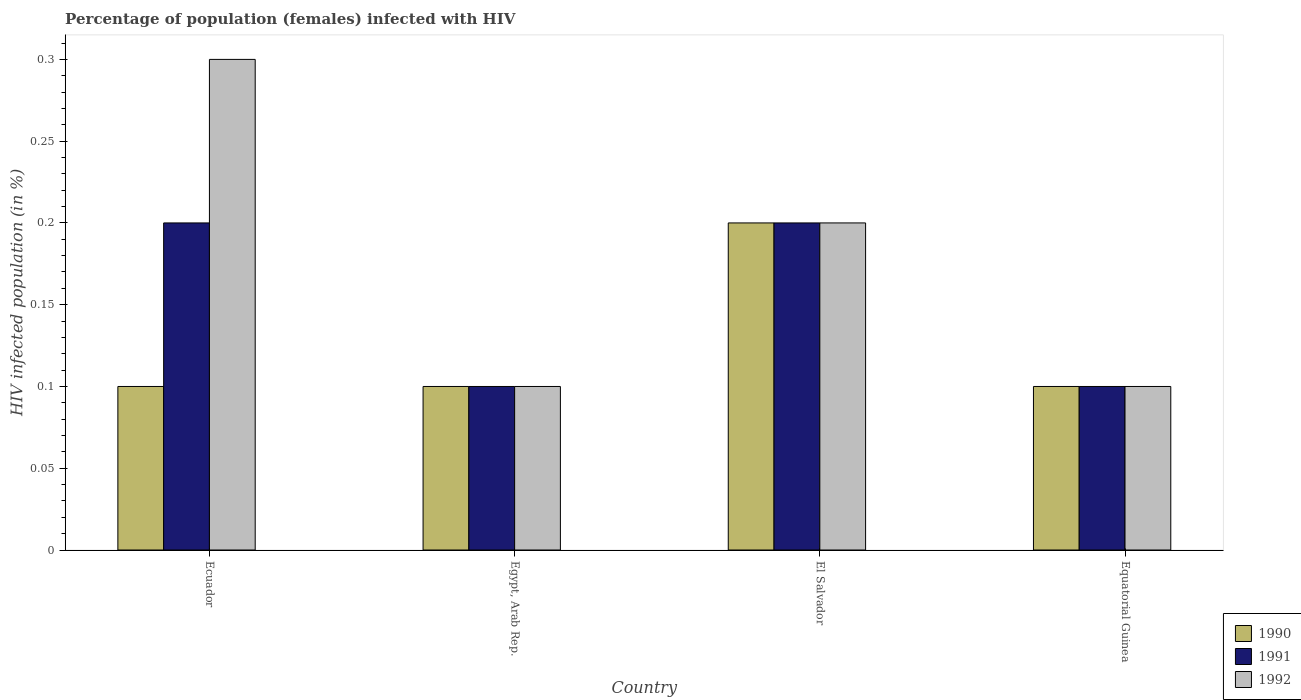How many different coloured bars are there?
Your answer should be very brief. 3. How many groups of bars are there?
Your answer should be compact. 4. How many bars are there on the 2nd tick from the left?
Keep it short and to the point. 3. What is the label of the 2nd group of bars from the left?
Make the answer very short. Egypt, Arab Rep. In how many cases, is the number of bars for a given country not equal to the number of legend labels?
Give a very brief answer. 0. What is the percentage of HIV infected female population in 1990 in Equatorial Guinea?
Your answer should be very brief. 0.1. In which country was the percentage of HIV infected female population in 1990 maximum?
Make the answer very short. El Salvador. In which country was the percentage of HIV infected female population in 1991 minimum?
Your answer should be compact. Egypt, Arab Rep. What is the difference between the percentage of HIV infected female population in 1990 in Egypt, Arab Rep. and the percentage of HIV infected female population in 1991 in Ecuador?
Offer a terse response. -0.1. What is the ratio of the percentage of HIV infected female population in 1990 in Egypt, Arab Rep. to that in El Salvador?
Ensure brevity in your answer.  0.5. Is the difference between the percentage of HIV infected female population in 1990 in Ecuador and Equatorial Guinea greater than the difference between the percentage of HIV infected female population in 1992 in Ecuador and Equatorial Guinea?
Keep it short and to the point. No. What is the difference between the highest and the second highest percentage of HIV infected female population in 1991?
Your answer should be very brief. 0.1. What does the 1st bar from the left in Equatorial Guinea represents?
Ensure brevity in your answer.  1990. Is it the case that in every country, the sum of the percentage of HIV infected female population in 1991 and percentage of HIV infected female population in 1992 is greater than the percentage of HIV infected female population in 1990?
Offer a terse response. Yes. Are the values on the major ticks of Y-axis written in scientific E-notation?
Your answer should be compact. No. Does the graph contain any zero values?
Offer a terse response. No. Where does the legend appear in the graph?
Provide a succinct answer. Bottom right. How many legend labels are there?
Provide a short and direct response. 3. What is the title of the graph?
Provide a succinct answer. Percentage of population (females) infected with HIV. Does "2003" appear as one of the legend labels in the graph?
Your answer should be very brief. No. What is the label or title of the Y-axis?
Your answer should be very brief. HIV infected population (in %). What is the HIV infected population (in %) of 1990 in Ecuador?
Give a very brief answer. 0.1. What is the HIV infected population (in %) in 1990 in Egypt, Arab Rep.?
Give a very brief answer. 0.1. What is the HIV infected population (in %) in 1991 in El Salvador?
Give a very brief answer. 0.2. Across all countries, what is the maximum HIV infected population (in %) in 1990?
Offer a very short reply. 0.2. Across all countries, what is the minimum HIV infected population (in %) in 1990?
Offer a very short reply. 0.1. Across all countries, what is the minimum HIV infected population (in %) in 1991?
Offer a very short reply. 0.1. What is the total HIV infected population (in %) in 1992 in the graph?
Give a very brief answer. 0.7. What is the difference between the HIV infected population (in %) of 1991 in Ecuador and that in El Salvador?
Offer a terse response. 0. What is the difference between the HIV infected population (in %) of 1992 in Ecuador and that in El Salvador?
Your answer should be compact. 0.1. What is the difference between the HIV infected population (in %) of 1990 in Ecuador and that in Equatorial Guinea?
Provide a succinct answer. 0. What is the difference between the HIV infected population (in %) in 1992 in Ecuador and that in Equatorial Guinea?
Your answer should be compact. 0.2. What is the difference between the HIV infected population (in %) in 1991 in Egypt, Arab Rep. and that in El Salvador?
Your response must be concise. -0.1. What is the difference between the HIV infected population (in %) of 1991 in Egypt, Arab Rep. and that in Equatorial Guinea?
Make the answer very short. 0. What is the difference between the HIV infected population (in %) in 1991 in El Salvador and that in Equatorial Guinea?
Your answer should be very brief. 0.1. What is the difference between the HIV infected population (in %) of 1992 in El Salvador and that in Equatorial Guinea?
Ensure brevity in your answer.  0.1. What is the difference between the HIV infected population (in %) in 1990 in Ecuador and the HIV infected population (in %) in 1991 in Egypt, Arab Rep.?
Make the answer very short. 0. What is the difference between the HIV infected population (in %) of 1990 in Ecuador and the HIV infected population (in %) of 1992 in Egypt, Arab Rep.?
Provide a short and direct response. 0. What is the difference between the HIV infected population (in %) in 1991 in Ecuador and the HIV infected population (in %) in 1992 in Egypt, Arab Rep.?
Your response must be concise. 0.1. What is the difference between the HIV infected population (in %) of 1990 in Ecuador and the HIV infected population (in %) of 1992 in El Salvador?
Your answer should be compact. -0.1. What is the difference between the HIV infected population (in %) in 1990 in Ecuador and the HIV infected population (in %) in 1991 in Equatorial Guinea?
Provide a short and direct response. 0. What is the difference between the HIV infected population (in %) in 1991 in Ecuador and the HIV infected population (in %) in 1992 in Equatorial Guinea?
Keep it short and to the point. 0.1. What is the difference between the HIV infected population (in %) of 1990 in Egypt, Arab Rep. and the HIV infected population (in %) of 1992 in El Salvador?
Give a very brief answer. -0.1. What is the difference between the HIV infected population (in %) in 1990 in El Salvador and the HIV infected population (in %) in 1991 in Equatorial Guinea?
Make the answer very short. 0.1. What is the difference between the HIV infected population (in %) of 1990 in El Salvador and the HIV infected population (in %) of 1992 in Equatorial Guinea?
Ensure brevity in your answer.  0.1. What is the difference between the HIV infected population (in %) of 1991 in El Salvador and the HIV infected population (in %) of 1992 in Equatorial Guinea?
Provide a short and direct response. 0.1. What is the average HIV infected population (in %) of 1990 per country?
Give a very brief answer. 0.12. What is the average HIV infected population (in %) of 1992 per country?
Offer a terse response. 0.17. What is the difference between the HIV infected population (in %) in 1991 and HIV infected population (in %) in 1992 in Egypt, Arab Rep.?
Offer a very short reply. 0. What is the difference between the HIV infected population (in %) in 1991 and HIV infected population (in %) in 1992 in El Salvador?
Provide a short and direct response. 0. What is the difference between the HIV infected population (in %) of 1990 and HIV infected population (in %) of 1991 in Equatorial Guinea?
Give a very brief answer. 0. What is the difference between the HIV infected population (in %) of 1990 and HIV infected population (in %) of 1992 in Equatorial Guinea?
Your answer should be compact. 0. What is the ratio of the HIV infected population (in %) in 1990 in Ecuador to that in Egypt, Arab Rep.?
Provide a short and direct response. 1. What is the ratio of the HIV infected population (in %) in 1992 in Ecuador to that in Egypt, Arab Rep.?
Provide a succinct answer. 3. What is the ratio of the HIV infected population (in %) in 1990 in Ecuador to that in El Salvador?
Offer a very short reply. 0.5. What is the ratio of the HIV infected population (in %) in 1991 in Ecuador to that in El Salvador?
Your answer should be compact. 1. What is the ratio of the HIV infected population (in %) of 1992 in Ecuador to that in El Salvador?
Your response must be concise. 1.5. What is the ratio of the HIV infected population (in %) of 1990 in Ecuador to that in Equatorial Guinea?
Offer a very short reply. 1. What is the ratio of the HIV infected population (in %) in 1991 in Ecuador to that in Equatorial Guinea?
Your answer should be compact. 2. What is the ratio of the HIV infected population (in %) in 1992 in Ecuador to that in Equatorial Guinea?
Keep it short and to the point. 3. What is the ratio of the HIV infected population (in %) of 1990 in Egypt, Arab Rep. to that in El Salvador?
Your answer should be compact. 0.5. What is the ratio of the HIV infected population (in %) of 1991 in Egypt, Arab Rep. to that in El Salvador?
Give a very brief answer. 0.5. What is the ratio of the HIV infected population (in %) in 1992 in Egypt, Arab Rep. to that in El Salvador?
Your response must be concise. 0.5. What is the ratio of the HIV infected population (in %) in 1991 in Egypt, Arab Rep. to that in Equatorial Guinea?
Your response must be concise. 1. What is the ratio of the HIV infected population (in %) of 1992 in Egypt, Arab Rep. to that in Equatorial Guinea?
Your answer should be compact. 1. What is the ratio of the HIV infected population (in %) in 1990 in El Salvador to that in Equatorial Guinea?
Provide a short and direct response. 2. What is the ratio of the HIV infected population (in %) in 1992 in El Salvador to that in Equatorial Guinea?
Ensure brevity in your answer.  2. What is the difference between the highest and the second highest HIV infected population (in %) in 1991?
Your response must be concise. 0. What is the difference between the highest and the second highest HIV infected population (in %) in 1992?
Give a very brief answer. 0.1. What is the difference between the highest and the lowest HIV infected population (in %) of 1990?
Give a very brief answer. 0.1. What is the difference between the highest and the lowest HIV infected population (in %) of 1991?
Make the answer very short. 0.1. 